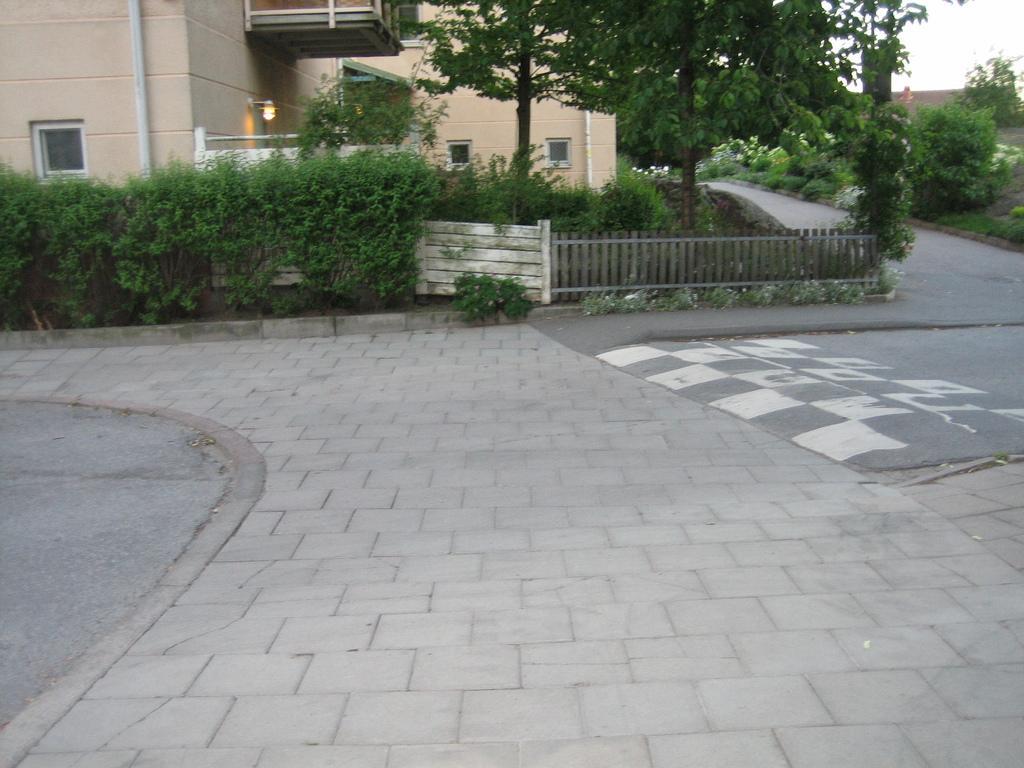Can you describe this image briefly? This picture is taken beside the road. At the bottom, there are trees, fence, plants, building etc. At the bottom, there are tiles. 